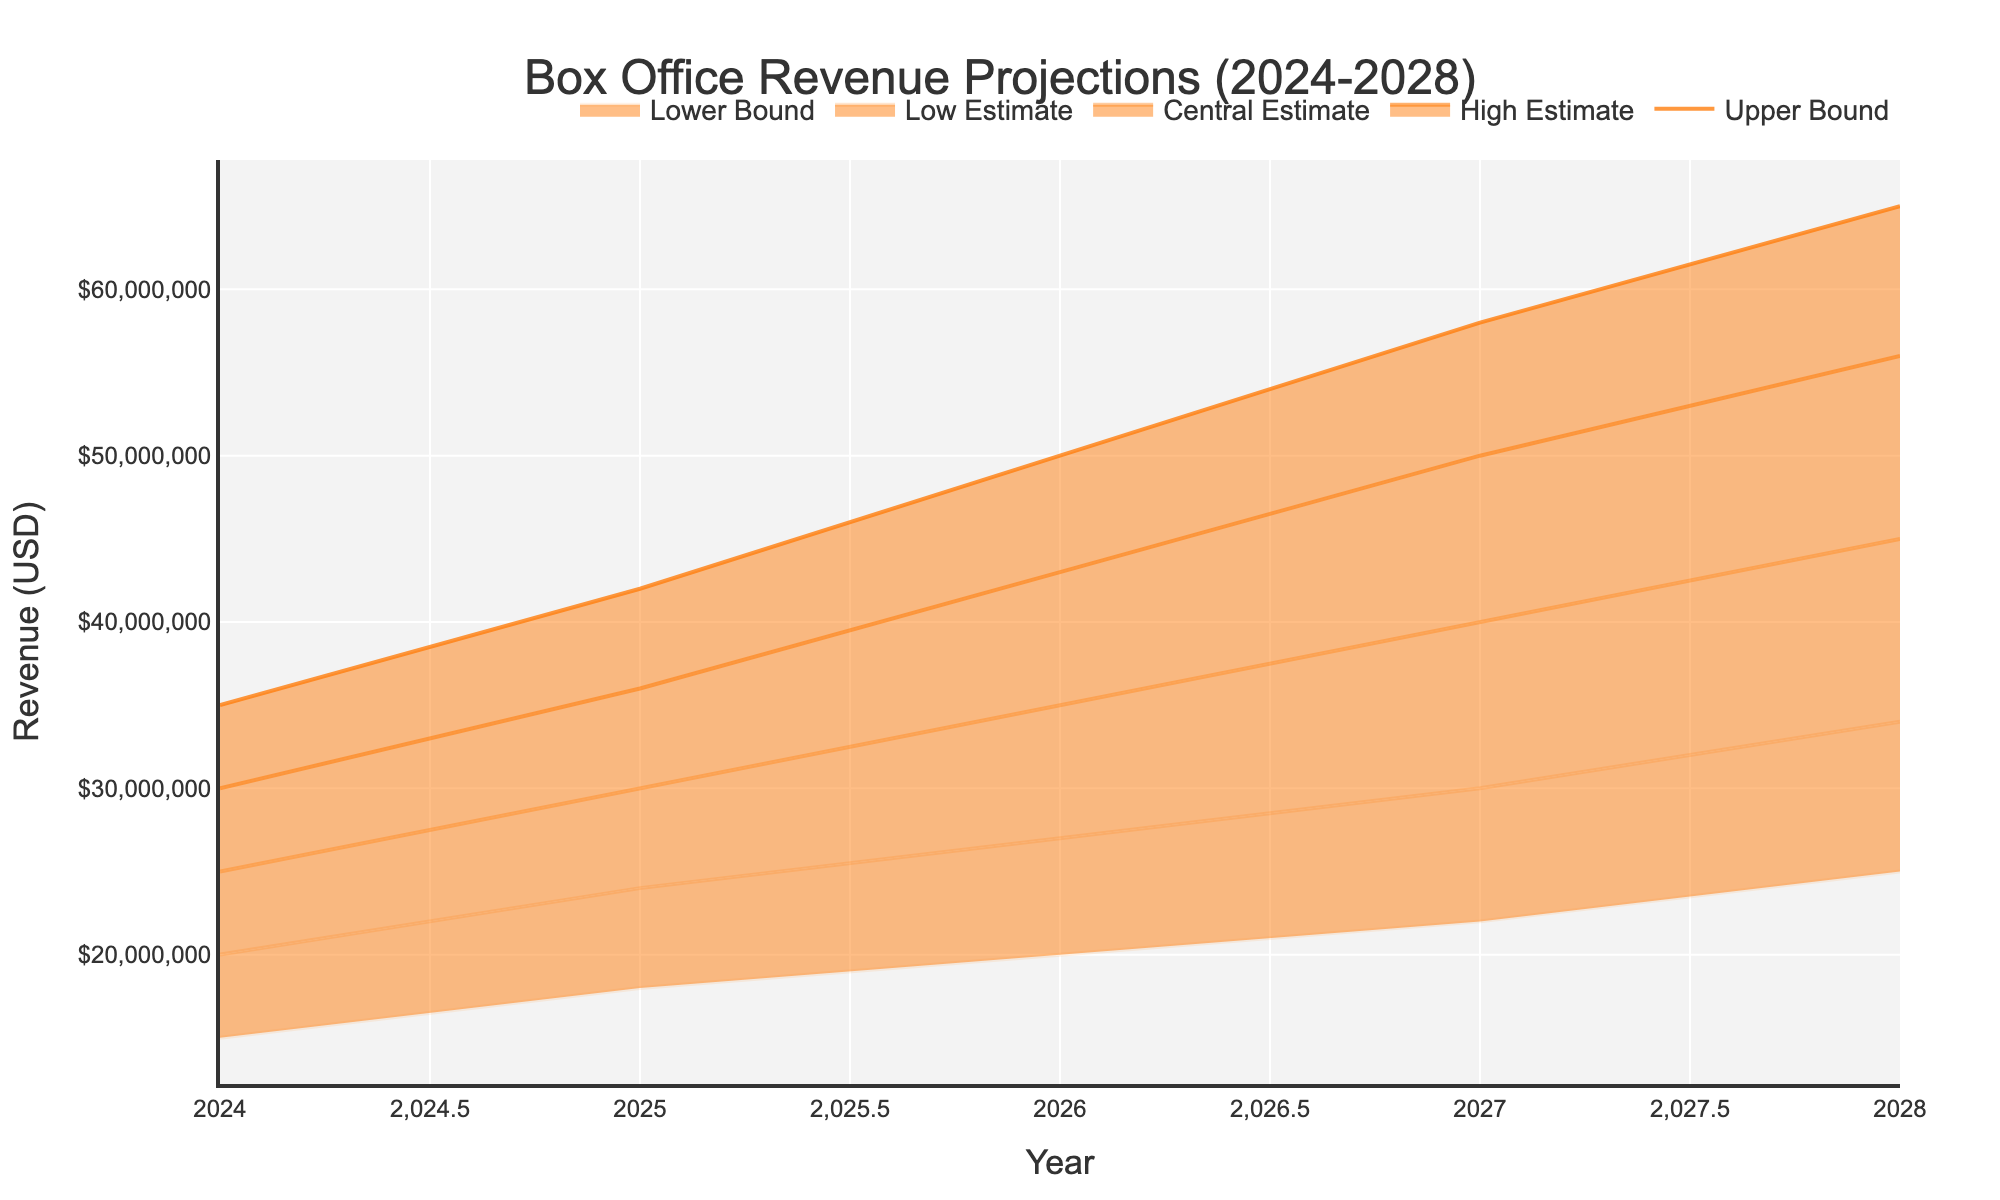what's the projected central estimate revenue in 2026? The central estimate for 2026 can be read directly from the chart under the “Central Estimate” line for the year 2026.
Answer: $35,000,000 what's the range of revenue projections in 2028? The range of revenue projections for 2028 can be found between the “Lower Bound” and “Upper Bound” lines. For 2028, it's from $25,000,000 to $65,000,000.
Answer: $25,000,000 to $65,000,000 how does the central estimate for 2025 compare to 2024? To compare the central estimates for 2025 and 2024, look at the “Central Estimate” lines for both years. For 2025, the central estimate is $30,000,000, and for 2024, it is $25,000,000.
Answer: 2025 is higher by $5,000,000 what year has the highest upper bound projection? To find the highest upper bound projection, look at the “Upper Bound” lines for all years and identify the maximum value. For 2028, the upper bound is $65,000,000.
Answer: 2028 what is the revenue increase from the central estimate of 2024 to the central estimate of 2028? The central estimate for 2024 is $25,000,000 and for 2028, it is $45,000,000. Subtract the 2024 estimate from the 2028 estimate to find the increase: $45,000,000 - $25,000,000 = $20,000,000.
Answer: $20,000,000 what's the average high estimate revenue over the forecast period? The high estimates over the years are: $30,000,000 (2024), $36,000,000 (2025), $43,000,000 (2026), $50,000,000 (2027), and $56,000,000 (2028). Sum them up: $30,000,000 + $36,000,000 + $43,000,000 + $50,000,000 + $56,000,000 = $215,000,000. Divide this by the number of years (5) to get the average: $215,000,000 / 5 = $43,000,000.
Answer: $43,000,000 which year shows the smallest difference between the high estimate and low estimate? To determine the year with the smallest difference, calculate the differences: 2024: $30,000,000 - $20,000,000 = $10,000,000; 2025: $36,000,000 - $24,000,000 = $12,000,000; 2026: $43,000,000 - $27,000,000 = $16,000,000; 2027: $50,000,000 - $30,000,000 = $20,000,000; 2028: $56,000,000 - $34,000,000 = $22,000,000. The smallest difference is in 2024.
Answer: 2024 what is the total projected revenue for the lower bound across all years? The lower bounds for the years are: $15,000,000 (2024), $18,000,000 (2025), $20,000,000 (2026), $22,000,000 (2027), and $25,000,000 (2028). Sum them up: $15,000,000 + $18,000,000 + $20,000,000 + $22,000,000 + $25,000,000 = $100,000,000.
Answer: $100,000,000 how much higher is the upper bound projection in 2028 compared to the upper bound projection in 2024? The upper bound in 2028 is $65,000,000, and in 2024, it is $35,000,000. Subtract the 2024 upper bound from the 2028 upper bound: $65,000,000 - $35,000,000 = $30,000,000.
Answer: $30,000,000 